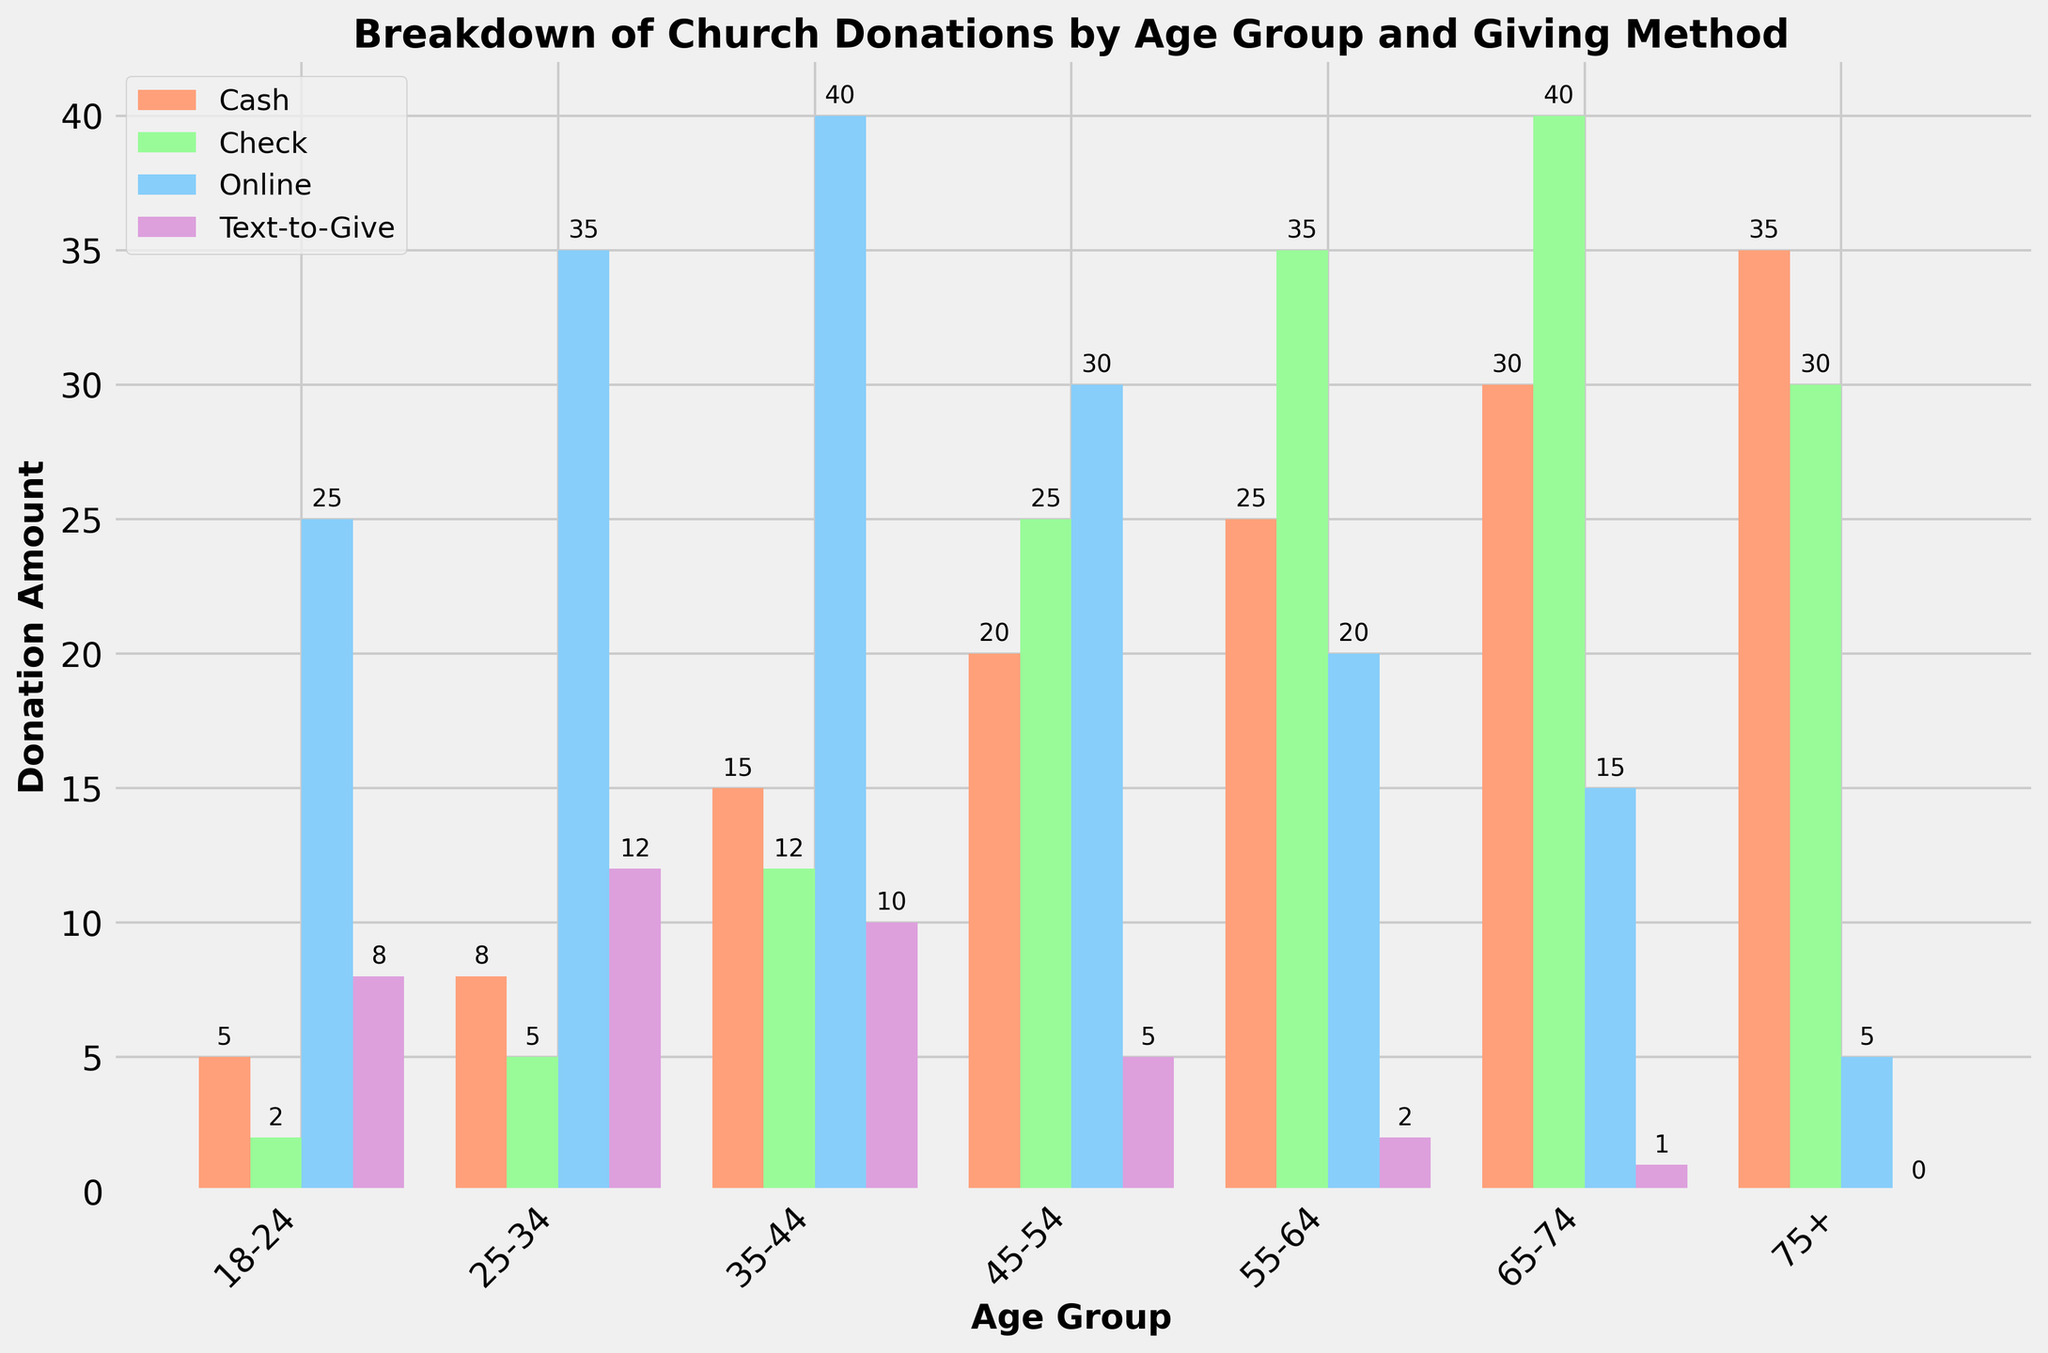Which age group contributes the most through cash donations? The age group that contributes the most through cash donations can be identified by looking at the highest bar in the 'Cash' category. The tallest one corresponds to the "75+" age group.
Answer: 75+ How much total donation does the 45-54 age group contribute via all methods? To find the total donations by the 45-54 age group, sum the heights of the bars corresponding to the 'Cash', 'Check', 'Online', and 'Text-to-Give' methods for this age group. This results in 20 (Cash) + 25 (Check) + 30 (Online) + 5 (Text-to-Give) = 80.
Answer: 80 Which giving method is most popular among the 18-24 age group? The most popular giving method can be identified by finding the tallest bar within the age group 18-24. The highest bar is the 'Online' donations category.
Answer: Online What is the difference in Check donations between the 25-34 age group and the 75+ age group? To find the difference, subtract the height of the Check bar for the 25-34 age group from the height of the Check bar for the 75+ age group. This results in 30 - 5 = 25.
Answer: 25 Which age group has the lowest text-to-give donations? The age group with the lowest text-to-give donations can be found by identifying the smallest bar in the 'Text-to-Give' category. The lowest value is in the "75+" age group.
Answer: 75+ How does online donations for the 55-64 age group compare to those for the 35-44 age group? To compare online donations, look at the height of the corresponding 'Online' bars for the 55-64 and 35-44 age groups. The 55-64 group has a lower value (20) compared to the 35-44 group (40).
Answer: Lower What is the total number of cash donations across all age groups? To find the total cash donations, sum the heights of all the bars in the 'Cash' category. This results in 5 + 8 + 15 + 20 + 25 + 30 + 35 = 138.
Answer: 138 In which age group is the difference between online and cash donations the most significant? The most significant difference can be found by determining the difference between the heights of the 'Online' and 'Cash' bars in each age group, then identifying the largest difference. The 25-34 age group has 35 (Online) - 8 (Cash) = 27, which is the largest difference.
Answer: 25-34 Which age group has nearly equal donations for cash and check methods? To determine this, compare the heights of the 'Cash' and 'Check' bars for each age group and find the one where the values are closest. The 75+ age group has fairly equal donations with 35 (Cash) and 30 (Check).
Answer: 75+ 